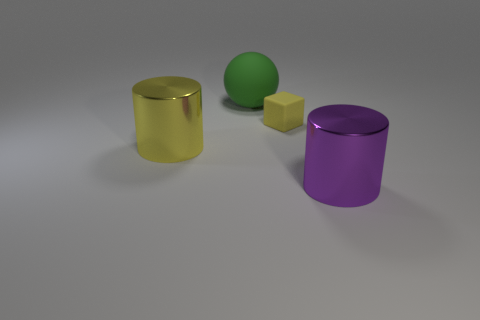Add 3 green matte spheres. How many objects exist? 7 Subtract all yellow cylinders. How many cylinders are left? 1 Subtract all spheres. How many objects are left? 3 Add 2 cubes. How many cubes are left? 3 Add 4 yellow matte blocks. How many yellow matte blocks exist? 5 Subtract 0 brown cylinders. How many objects are left? 4 Subtract 1 spheres. How many spheres are left? 0 Subtract all brown cylinders. Subtract all blue balls. How many cylinders are left? 2 Subtract all purple spheres. How many yellow cylinders are left? 1 Subtract all tiny gray spheres. Subtract all small rubber objects. How many objects are left? 3 